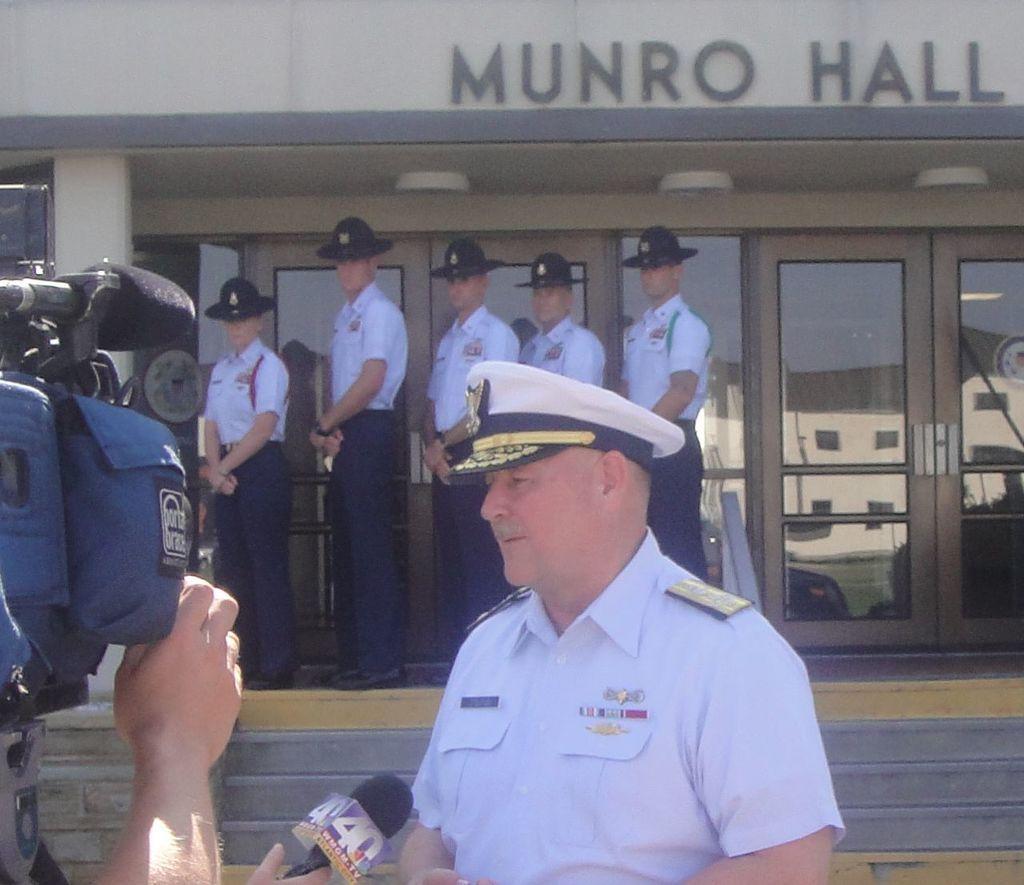Describe this image in one or two sentences. On the left side, there is a person holding a camera and there is a person holding a mic with a hand. On the right side, there is a person in white color shirt, standing. In the background, there are persons in white color shirts, wearing black color helmets and standing in a line on a floor of a building which is having glass doors, steps and a hoarding on the wall. 